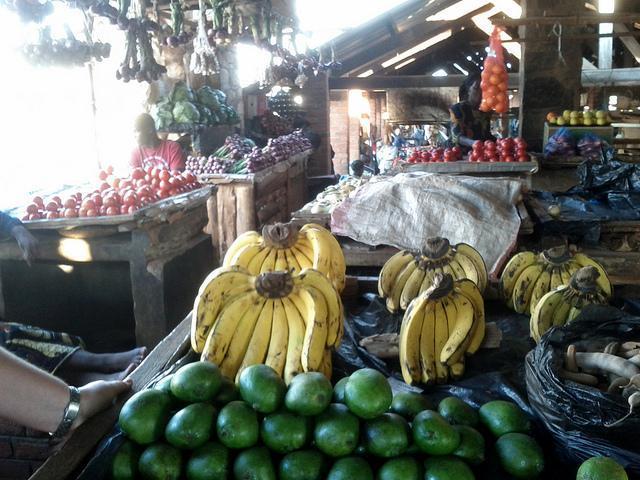How many banana bunches are there?
Give a very brief answer. 6. How many people are in the photo?
Give a very brief answer. 2. How many bananas are in the photo?
Give a very brief answer. 6. 